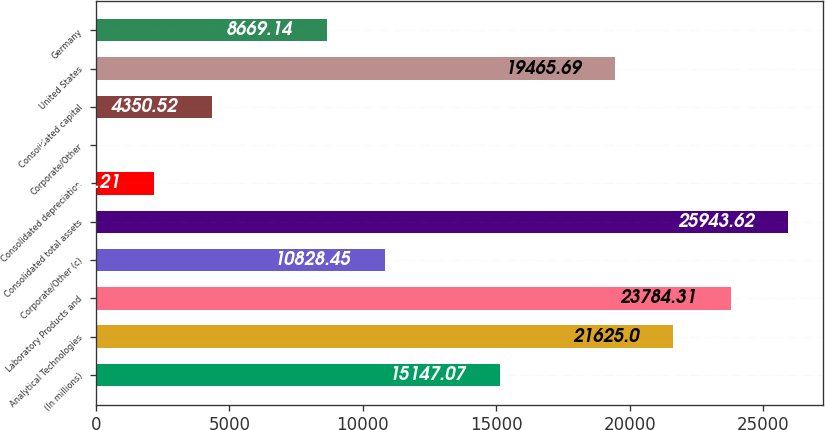<chart> <loc_0><loc_0><loc_500><loc_500><bar_chart><fcel>(In millions)<fcel>Analytical Technologies<fcel>Laboratory Products and<fcel>Corporate/Other (c)<fcel>Consolidated total assets<fcel>Consolidated depreciation<fcel>Corporate/Other<fcel>Consolidated capital<fcel>United States<fcel>Germany<nl><fcel>15147.1<fcel>21625<fcel>23784.3<fcel>10828.5<fcel>25943.6<fcel>2191.21<fcel>31.9<fcel>4350.52<fcel>19465.7<fcel>8669.14<nl></chart> 